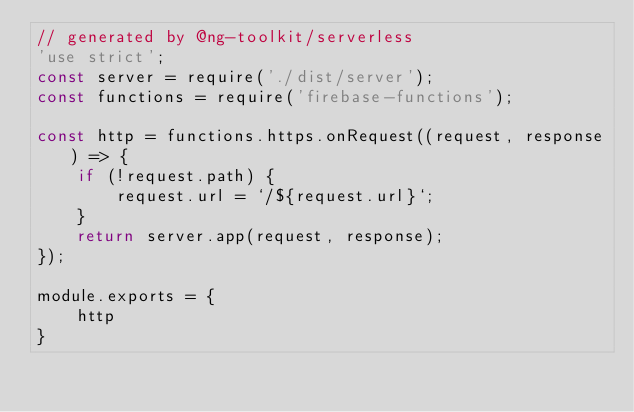<code> <loc_0><loc_0><loc_500><loc_500><_JavaScript_>// generated by @ng-toolkit/serverless
'use strict';
const server = require('./dist/server');
const functions = require('firebase-functions');

const http = functions.https.onRequest((request, response) => {
    if (!request.path) {
        request.url = `/${request.url}`;
    }
    return server.app(request, response);
});

module.exports = {
    http
}
</code> 